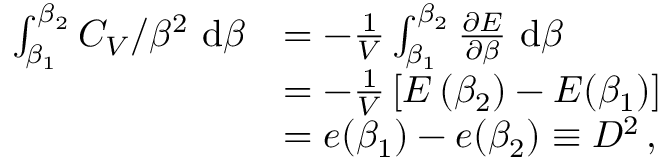<formula> <loc_0><loc_0><loc_500><loc_500>\begin{array} { r l } { \int _ { \beta _ { 1 } } ^ { \beta _ { 2 } } C _ { V } / \beta ^ { 2 } \mathrm d \beta } & { = - \frac { 1 } { V } \int _ { \beta _ { 1 } } ^ { \beta _ { 2 } } \frac { \partial E } { \partial \beta } \mathrm d \beta } \\ & { = - \frac { 1 } { V } \left [ E \left ( \beta _ { 2 } \right ) - E ( \beta _ { 1 } ) \right ] } \\ & { = e ( \beta _ { 1 } ) - e ( \beta _ { 2 } ) \equiv D ^ { 2 } \, , } \end{array}</formula> 